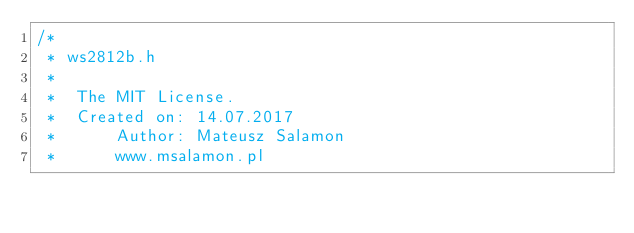<code> <loc_0><loc_0><loc_500><loc_500><_C_>/*
 * ws2812b.h
 *
 *	The MIT License.
 *	Created on: 14.07.2017
 *		Author: Mateusz Salamon
 *		www.msalamon.pl</code> 